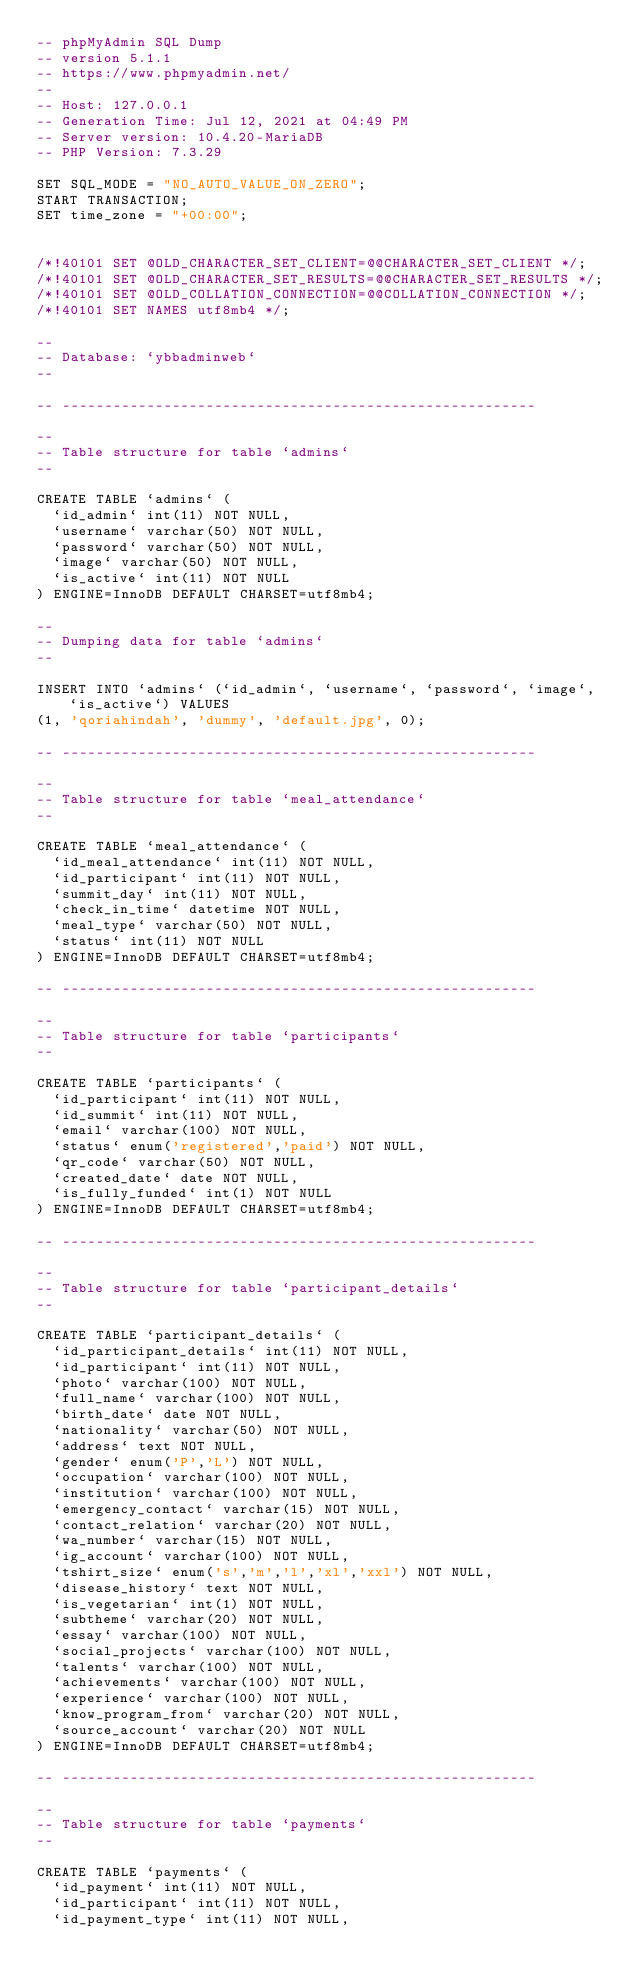<code> <loc_0><loc_0><loc_500><loc_500><_SQL_>-- phpMyAdmin SQL Dump
-- version 5.1.1
-- https://www.phpmyadmin.net/
--
-- Host: 127.0.0.1
-- Generation Time: Jul 12, 2021 at 04:49 PM
-- Server version: 10.4.20-MariaDB
-- PHP Version: 7.3.29

SET SQL_MODE = "NO_AUTO_VALUE_ON_ZERO";
START TRANSACTION;
SET time_zone = "+00:00";


/*!40101 SET @OLD_CHARACTER_SET_CLIENT=@@CHARACTER_SET_CLIENT */;
/*!40101 SET @OLD_CHARACTER_SET_RESULTS=@@CHARACTER_SET_RESULTS */;
/*!40101 SET @OLD_COLLATION_CONNECTION=@@COLLATION_CONNECTION */;
/*!40101 SET NAMES utf8mb4 */;

--
-- Database: `ybbadminweb`
--

-- --------------------------------------------------------

--
-- Table structure for table `admins`
--

CREATE TABLE `admins` (
  `id_admin` int(11) NOT NULL,
  `username` varchar(50) NOT NULL,
  `password` varchar(50) NOT NULL,
  `image` varchar(50) NOT NULL,
  `is_active` int(11) NOT NULL
) ENGINE=InnoDB DEFAULT CHARSET=utf8mb4;

--
-- Dumping data for table `admins`
--

INSERT INTO `admins` (`id_admin`, `username`, `password`, `image`, `is_active`) VALUES
(1, 'qoriahindah', 'dummy', 'default.jpg', 0);

-- --------------------------------------------------------

--
-- Table structure for table `meal_attendance`
--

CREATE TABLE `meal_attendance` (
  `id_meal_attendance` int(11) NOT NULL,
  `id_participant` int(11) NOT NULL,
  `summit_day` int(11) NOT NULL,
  `check_in_time` datetime NOT NULL,
  `meal_type` varchar(50) NOT NULL,
  `status` int(11) NOT NULL
) ENGINE=InnoDB DEFAULT CHARSET=utf8mb4;

-- --------------------------------------------------------

--
-- Table structure for table `participants`
--

CREATE TABLE `participants` (
  `id_participant` int(11) NOT NULL,
  `id_summit` int(11) NOT NULL,
  `email` varchar(100) NOT NULL,
  `status` enum('registered','paid') NOT NULL,
  `qr_code` varchar(50) NOT NULL,
  `created_date` date NOT NULL,
  `is_fully_funded` int(1) NOT NULL
) ENGINE=InnoDB DEFAULT CHARSET=utf8mb4;

-- --------------------------------------------------------

--
-- Table structure for table `participant_details`
--

CREATE TABLE `participant_details` (
  `id_participant_details` int(11) NOT NULL,
  `id_participant` int(11) NOT NULL,
  `photo` varchar(100) NOT NULL,
  `full_name` varchar(100) NOT NULL,
  `birth_date` date NOT NULL,
  `nationality` varchar(50) NOT NULL,
  `address` text NOT NULL,
  `gender` enum('P','L') NOT NULL,
  `occupation` varchar(100) NOT NULL,
  `institution` varchar(100) NOT NULL,
  `emergency_contact` varchar(15) NOT NULL,
  `contact_relation` varchar(20) NOT NULL,
  `wa_number` varchar(15) NOT NULL,
  `ig_account` varchar(100) NOT NULL,
  `tshirt_size` enum('s','m','l','xl','xxl') NOT NULL,
  `disease_history` text NOT NULL,
  `is_vegetarian` int(1) NOT NULL,
  `subtheme` varchar(20) NOT NULL,
  `essay` varchar(100) NOT NULL,
  `social_projects` varchar(100) NOT NULL,
  `talents` varchar(100) NOT NULL,
  `achievements` varchar(100) NOT NULL,
  `experience` varchar(100) NOT NULL,
  `know_program_from` varchar(20) NOT NULL,
  `source_account` varchar(20) NOT NULL
) ENGINE=InnoDB DEFAULT CHARSET=utf8mb4;

-- --------------------------------------------------------

--
-- Table structure for table `payments`
--

CREATE TABLE `payments` (
  `id_payment` int(11) NOT NULL,
  `id_participant` int(11) NOT NULL,
  `id_payment_type` int(11) NOT NULL,</code> 